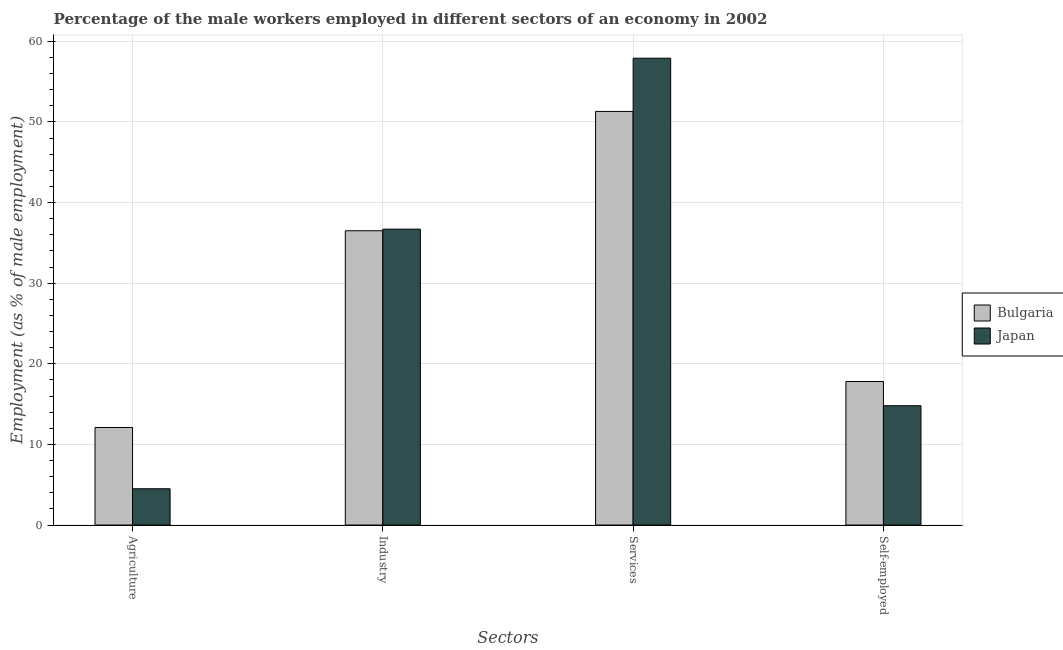How many different coloured bars are there?
Your response must be concise. 2. Are the number of bars on each tick of the X-axis equal?
Offer a terse response. Yes. What is the label of the 3rd group of bars from the left?
Make the answer very short. Services. What is the percentage of male workers in services in Japan?
Your response must be concise. 57.9. Across all countries, what is the maximum percentage of male workers in services?
Keep it short and to the point. 57.9. Across all countries, what is the minimum percentage of male workers in industry?
Your answer should be very brief. 36.5. What is the total percentage of male workers in services in the graph?
Offer a very short reply. 109.2. What is the difference between the percentage of self employed male workers in Bulgaria and that in Japan?
Offer a very short reply. 3. What is the difference between the percentage of male workers in services in Bulgaria and the percentage of male workers in agriculture in Japan?
Keep it short and to the point. 46.8. What is the average percentage of male workers in agriculture per country?
Provide a short and direct response. 8.3. What is the difference between the percentage of male workers in industry and percentage of male workers in agriculture in Japan?
Offer a terse response. 32.2. What is the ratio of the percentage of self employed male workers in Bulgaria to that in Japan?
Make the answer very short. 1.2. What is the difference between the highest and the second highest percentage of male workers in agriculture?
Your response must be concise. 7.6. What is the difference between the highest and the lowest percentage of self employed male workers?
Offer a terse response. 3. In how many countries, is the percentage of male workers in services greater than the average percentage of male workers in services taken over all countries?
Your answer should be compact. 1. Is it the case that in every country, the sum of the percentage of male workers in agriculture and percentage of male workers in services is greater than the sum of percentage of self employed male workers and percentage of male workers in industry?
Provide a short and direct response. No. What does the 1st bar from the right in Industry represents?
Ensure brevity in your answer.  Japan. Is it the case that in every country, the sum of the percentage of male workers in agriculture and percentage of male workers in industry is greater than the percentage of male workers in services?
Provide a succinct answer. No. How many bars are there?
Provide a succinct answer. 8. Are all the bars in the graph horizontal?
Provide a succinct answer. No. What is the difference between two consecutive major ticks on the Y-axis?
Provide a succinct answer. 10. Does the graph contain any zero values?
Offer a terse response. No. Does the graph contain grids?
Give a very brief answer. Yes. What is the title of the graph?
Offer a terse response. Percentage of the male workers employed in different sectors of an economy in 2002. Does "Romania" appear as one of the legend labels in the graph?
Make the answer very short. No. What is the label or title of the X-axis?
Offer a terse response. Sectors. What is the label or title of the Y-axis?
Offer a very short reply. Employment (as % of male employment). What is the Employment (as % of male employment) in Bulgaria in Agriculture?
Keep it short and to the point. 12.1. What is the Employment (as % of male employment) in Japan in Agriculture?
Offer a very short reply. 4.5. What is the Employment (as % of male employment) in Bulgaria in Industry?
Provide a succinct answer. 36.5. What is the Employment (as % of male employment) of Japan in Industry?
Your answer should be very brief. 36.7. What is the Employment (as % of male employment) of Bulgaria in Services?
Provide a short and direct response. 51.3. What is the Employment (as % of male employment) of Japan in Services?
Your answer should be compact. 57.9. What is the Employment (as % of male employment) in Bulgaria in Self-employed?
Your answer should be very brief. 17.8. What is the Employment (as % of male employment) in Japan in Self-employed?
Make the answer very short. 14.8. Across all Sectors, what is the maximum Employment (as % of male employment) of Bulgaria?
Give a very brief answer. 51.3. Across all Sectors, what is the maximum Employment (as % of male employment) of Japan?
Offer a terse response. 57.9. Across all Sectors, what is the minimum Employment (as % of male employment) in Bulgaria?
Make the answer very short. 12.1. What is the total Employment (as % of male employment) in Bulgaria in the graph?
Offer a terse response. 117.7. What is the total Employment (as % of male employment) in Japan in the graph?
Ensure brevity in your answer.  113.9. What is the difference between the Employment (as % of male employment) in Bulgaria in Agriculture and that in Industry?
Your answer should be very brief. -24.4. What is the difference between the Employment (as % of male employment) of Japan in Agriculture and that in Industry?
Offer a terse response. -32.2. What is the difference between the Employment (as % of male employment) of Bulgaria in Agriculture and that in Services?
Provide a short and direct response. -39.2. What is the difference between the Employment (as % of male employment) of Japan in Agriculture and that in Services?
Ensure brevity in your answer.  -53.4. What is the difference between the Employment (as % of male employment) of Bulgaria in Agriculture and that in Self-employed?
Ensure brevity in your answer.  -5.7. What is the difference between the Employment (as % of male employment) in Bulgaria in Industry and that in Services?
Provide a short and direct response. -14.8. What is the difference between the Employment (as % of male employment) of Japan in Industry and that in Services?
Give a very brief answer. -21.2. What is the difference between the Employment (as % of male employment) of Japan in Industry and that in Self-employed?
Your response must be concise. 21.9. What is the difference between the Employment (as % of male employment) in Bulgaria in Services and that in Self-employed?
Ensure brevity in your answer.  33.5. What is the difference between the Employment (as % of male employment) in Japan in Services and that in Self-employed?
Make the answer very short. 43.1. What is the difference between the Employment (as % of male employment) of Bulgaria in Agriculture and the Employment (as % of male employment) of Japan in Industry?
Ensure brevity in your answer.  -24.6. What is the difference between the Employment (as % of male employment) of Bulgaria in Agriculture and the Employment (as % of male employment) of Japan in Services?
Your answer should be very brief. -45.8. What is the difference between the Employment (as % of male employment) in Bulgaria in Industry and the Employment (as % of male employment) in Japan in Services?
Keep it short and to the point. -21.4. What is the difference between the Employment (as % of male employment) in Bulgaria in Industry and the Employment (as % of male employment) in Japan in Self-employed?
Your answer should be compact. 21.7. What is the difference between the Employment (as % of male employment) in Bulgaria in Services and the Employment (as % of male employment) in Japan in Self-employed?
Give a very brief answer. 36.5. What is the average Employment (as % of male employment) in Bulgaria per Sectors?
Give a very brief answer. 29.43. What is the average Employment (as % of male employment) of Japan per Sectors?
Your response must be concise. 28.48. What is the difference between the Employment (as % of male employment) of Bulgaria and Employment (as % of male employment) of Japan in Agriculture?
Provide a short and direct response. 7.6. What is the difference between the Employment (as % of male employment) in Bulgaria and Employment (as % of male employment) in Japan in Industry?
Offer a terse response. -0.2. What is the difference between the Employment (as % of male employment) in Bulgaria and Employment (as % of male employment) in Japan in Self-employed?
Make the answer very short. 3. What is the ratio of the Employment (as % of male employment) of Bulgaria in Agriculture to that in Industry?
Offer a very short reply. 0.33. What is the ratio of the Employment (as % of male employment) in Japan in Agriculture to that in Industry?
Your answer should be very brief. 0.12. What is the ratio of the Employment (as % of male employment) of Bulgaria in Agriculture to that in Services?
Keep it short and to the point. 0.24. What is the ratio of the Employment (as % of male employment) of Japan in Agriculture to that in Services?
Your answer should be very brief. 0.08. What is the ratio of the Employment (as % of male employment) in Bulgaria in Agriculture to that in Self-employed?
Your answer should be compact. 0.68. What is the ratio of the Employment (as % of male employment) in Japan in Agriculture to that in Self-employed?
Provide a succinct answer. 0.3. What is the ratio of the Employment (as % of male employment) in Bulgaria in Industry to that in Services?
Give a very brief answer. 0.71. What is the ratio of the Employment (as % of male employment) of Japan in Industry to that in Services?
Make the answer very short. 0.63. What is the ratio of the Employment (as % of male employment) in Bulgaria in Industry to that in Self-employed?
Give a very brief answer. 2.05. What is the ratio of the Employment (as % of male employment) in Japan in Industry to that in Self-employed?
Offer a terse response. 2.48. What is the ratio of the Employment (as % of male employment) of Bulgaria in Services to that in Self-employed?
Your response must be concise. 2.88. What is the ratio of the Employment (as % of male employment) in Japan in Services to that in Self-employed?
Keep it short and to the point. 3.91. What is the difference between the highest and the second highest Employment (as % of male employment) of Bulgaria?
Your response must be concise. 14.8. What is the difference between the highest and the second highest Employment (as % of male employment) in Japan?
Your response must be concise. 21.2. What is the difference between the highest and the lowest Employment (as % of male employment) of Bulgaria?
Keep it short and to the point. 39.2. What is the difference between the highest and the lowest Employment (as % of male employment) in Japan?
Keep it short and to the point. 53.4. 